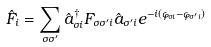Convert formula to latex. <formula><loc_0><loc_0><loc_500><loc_500>\hat { F } _ { i } = \sum _ { \sigma \sigma ^ { \prime } } \hat { a } ^ { \dagger } _ { \sigma i } { F } _ { \sigma \sigma ^ { \prime } i } \hat { a } _ { \sigma ^ { \prime } i } e ^ { - i ( \varphi _ { \sigma i } - \varphi _ { \sigma ^ { \prime } i } ) }</formula> 